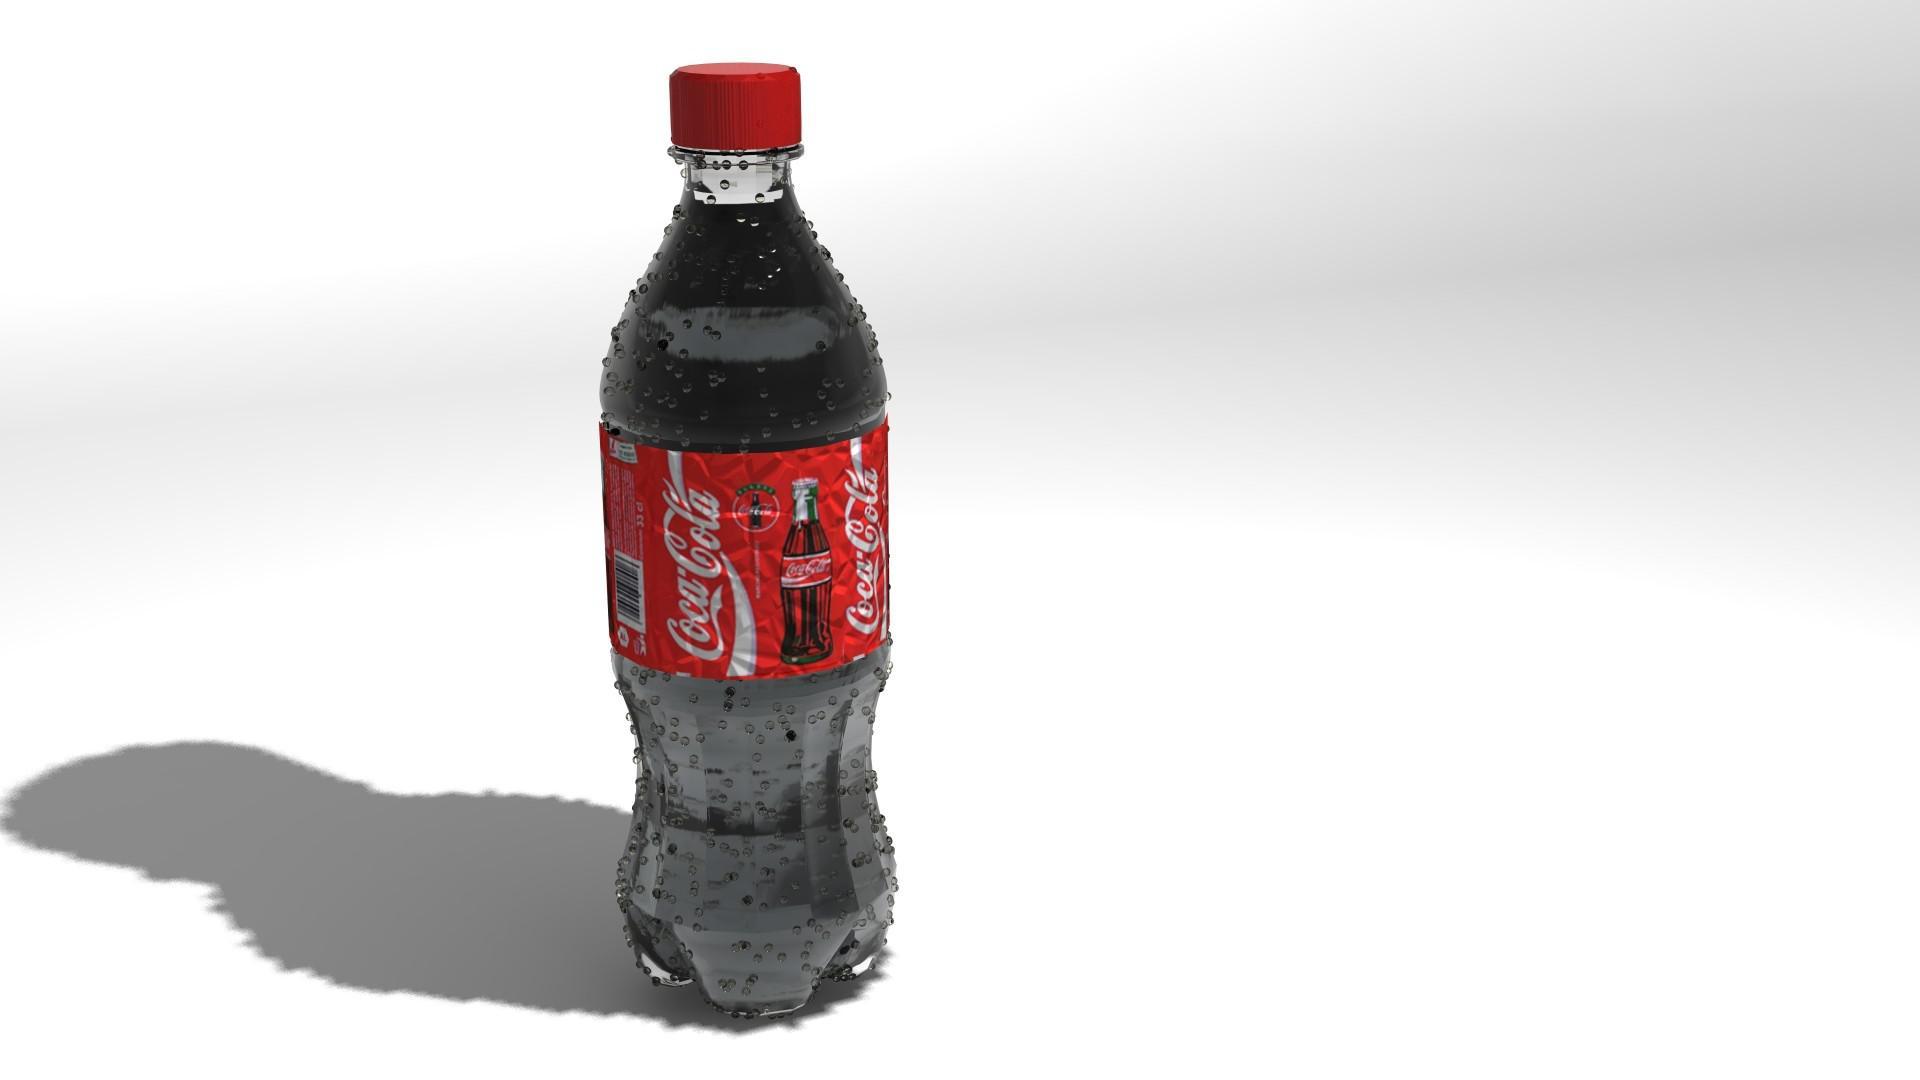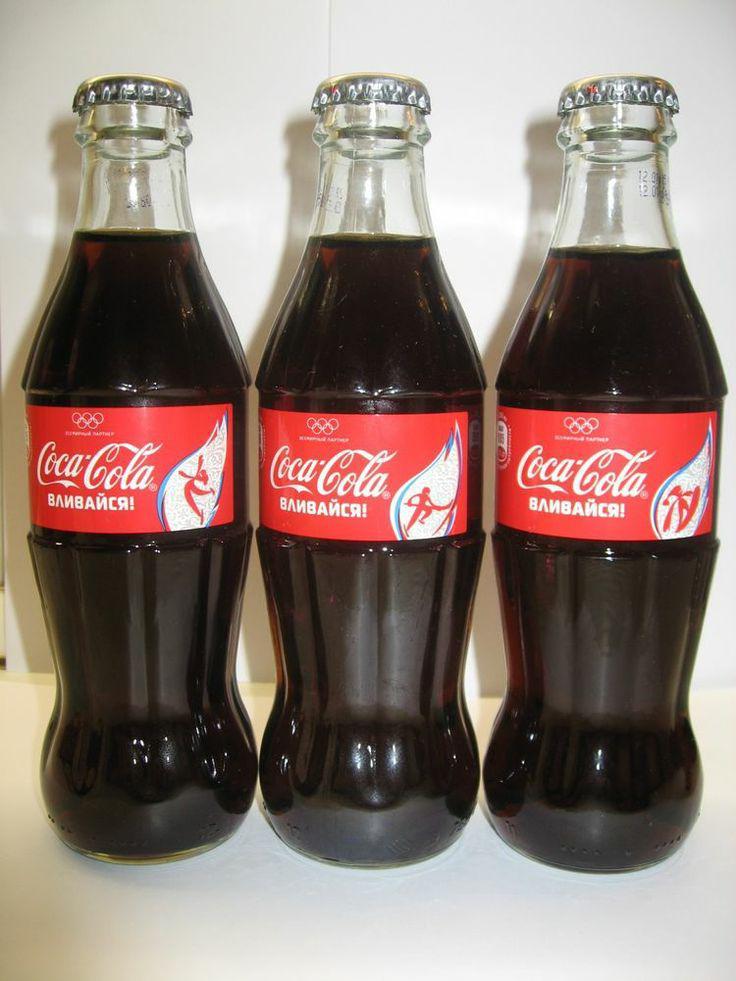The first image is the image on the left, the second image is the image on the right. For the images displayed, is the sentence "There are no more than four bottles of soda." factually correct? Answer yes or no. Yes. The first image is the image on the left, the second image is the image on the right. Considering the images on both sides, is "There is only one bottle in one of the images." valid? Answer yes or no. Yes. 